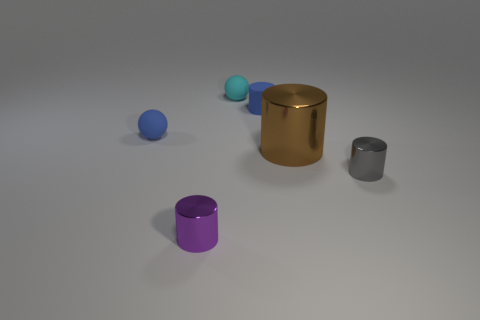Subtract all large brown cylinders. How many cylinders are left? 3 Subtract 1 cylinders. How many cylinders are left? 3 Subtract all purple cylinders. How many cylinders are left? 3 Subtract all yellow cylinders. Subtract all green cubes. How many cylinders are left? 4 Add 1 gray metallic cylinders. How many objects exist? 7 Subtract all balls. How many objects are left? 4 Subtract all brown shiny cubes. Subtract all big things. How many objects are left? 5 Add 1 blue cylinders. How many blue cylinders are left? 2 Add 1 small rubber cylinders. How many small rubber cylinders exist? 2 Subtract 0 gray balls. How many objects are left? 6 